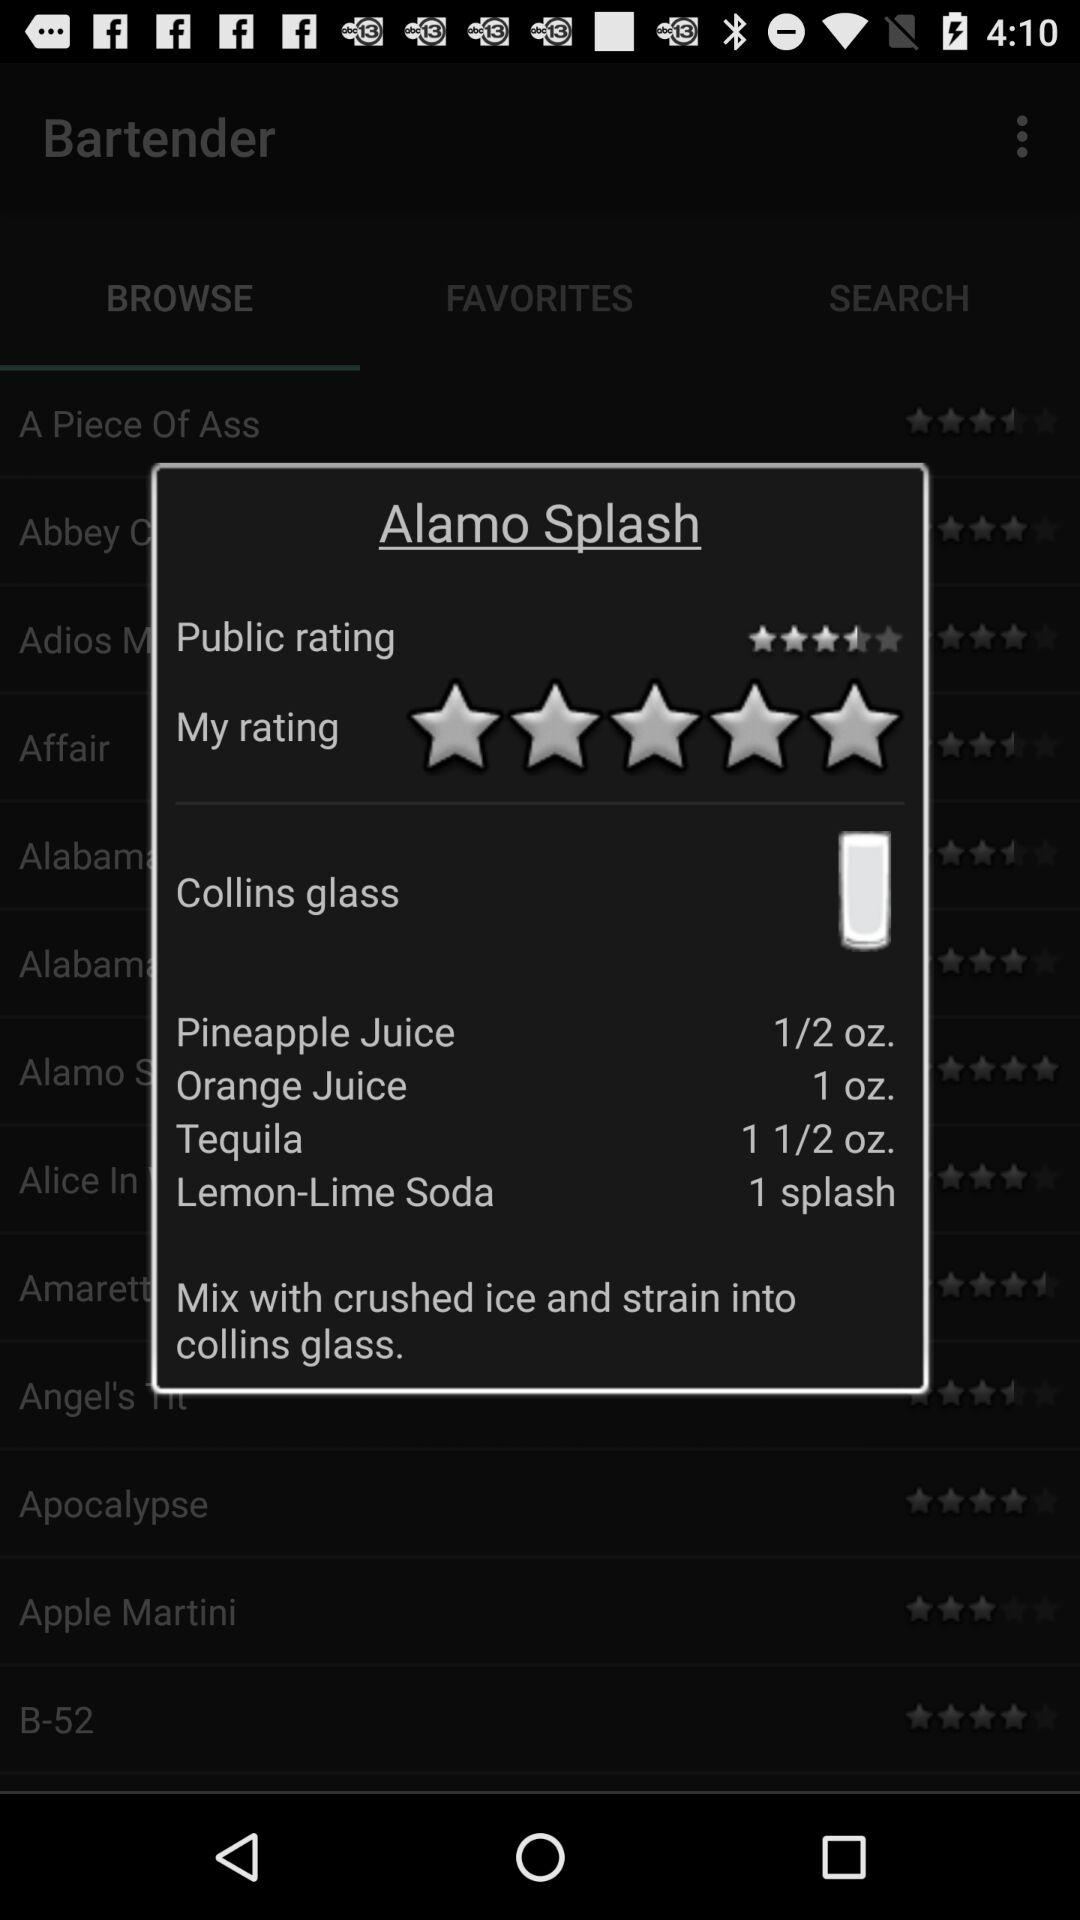What is the quantity of tequila required for Alamo Splash? The quantity of tequila required for Alamo Splash is an ounce and a half. 